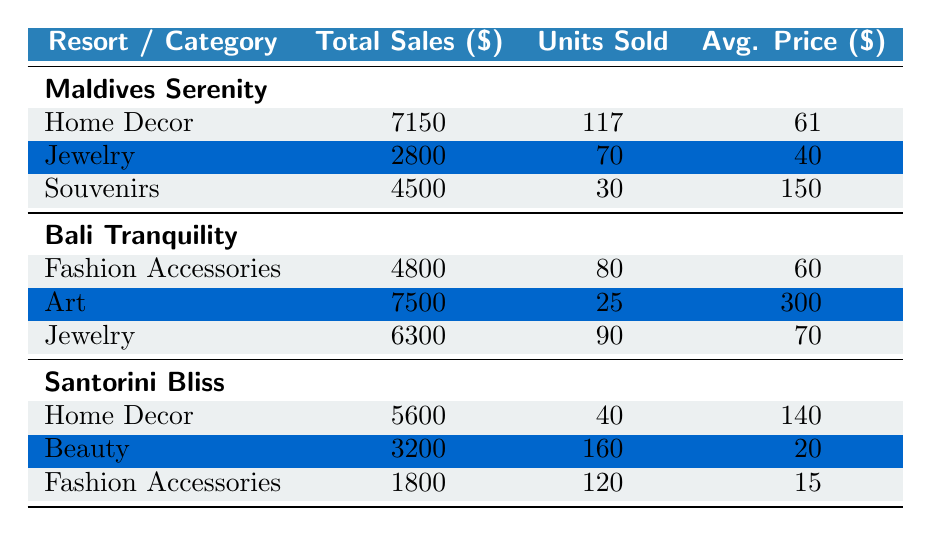What is the total sales for Maldives Serenity? To find the total sales for Maldives Serenity, we look at the "Total Sales" for each category under that resort. The totals are: Home Decor (7150), Jewelry (2800), and Souvenirs (4500). Adding these together gives us 7150 + 2800 + 4500 = 14450.
Answer: 14450 Which product had the highest average price in Bali Tranquility? For Bali Tranquility, we need to look at the average price for each category: Fashion Accessories (60), Art (300), and Jewelry (70). The highest average price is from the Art category, which is 300.
Answer: 300 How many units were sold for Beauty products in Santorini Bliss? We can check the category details for Santorini Bliss. The Beauty category shows a total of 160 units sold. Therefore, the answer is the value directly listed in the table.
Answer: 160 Are there more units sold in Home Decor for Maldives Serenity compared to Santorini Bliss? For Maldives Serenity, the units sold in Home Decor is 117. For Santorini Bliss, the units sold in Home Decor is 40. Since 117 is greater than 40, we can conclude that more units were sold in Maldives Serenity.
Answer: Yes What is the total sales of Jewelry across all resorts? To find the total sales for Jewelry, we sum the sales values from each resort's Jewelry category: Maldives Serenity (2800), Bali Tranquility (6300). Thus, the total sales is 2800 + 6300 = 9100.
Answer: 9100 Which resort generated the least total sales? Looking at the total sales values for all resorts, we have: Maldives Serenity (14450), Bali Tranquility (18600), and Santorini Bliss (10600). The lowest is Santorini Bliss with 10600.
Answer: Santorini Bliss What is the average price per unit sold for souvenirs in Maldives Serenity? The total sales for Souvenirs in Maldives Serenity is 4500, and the units sold is 30. To find the average price, we calculate 4500 divided by 30 which gives us an average price of 150.
Answer: 150 Did Santorini Bliss sell more of the Home Decor category than Maldives Serenity? In Maldives Serenity, the sold units for Home Decor is 117. For Santorini Bliss, it’s 40. Since 117 is greater than 40, we can affirmatively answer that Santorini Bliss did not sell more.
Answer: No Which product category had the highest total sales across all resorts? Summing the total sales for each product category provides the overall totals: Home Decor (7150 + 5600 = 12750), Fashion Accessories (4800 + 1800 = 6600), Jewelry (2800 + 6300 = 9100), Art (7500), and Beauty (3200). The highest total sales are from Home Decor at 12750.
Answer: Home Decor 